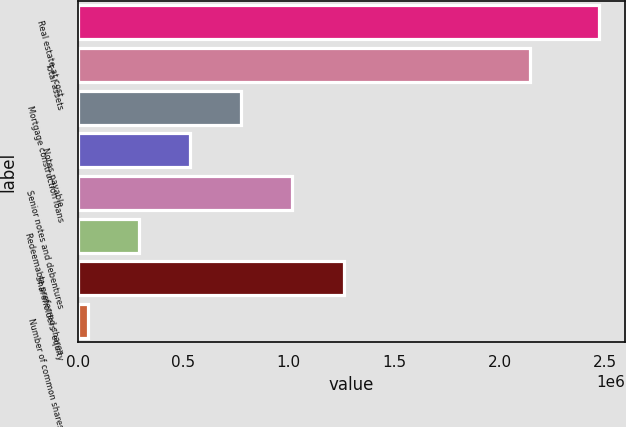Convert chart. <chart><loc_0><loc_0><loc_500><loc_500><bar_chart><fcel>Real estate at cost<fcel>Total assets<fcel>Mortgage construction loans<fcel>Notes payable<fcel>Senior notes and debentures<fcel>Redeemable preferred shares<fcel>Shareholders' equity<fcel>Number of common shares<nl><fcel>2.47015e+06<fcel>2.14118e+06<fcel>775485<fcel>533391<fcel>1.01758e+06<fcel>291296<fcel>1.25968e+06<fcel>49201<nl></chart> 